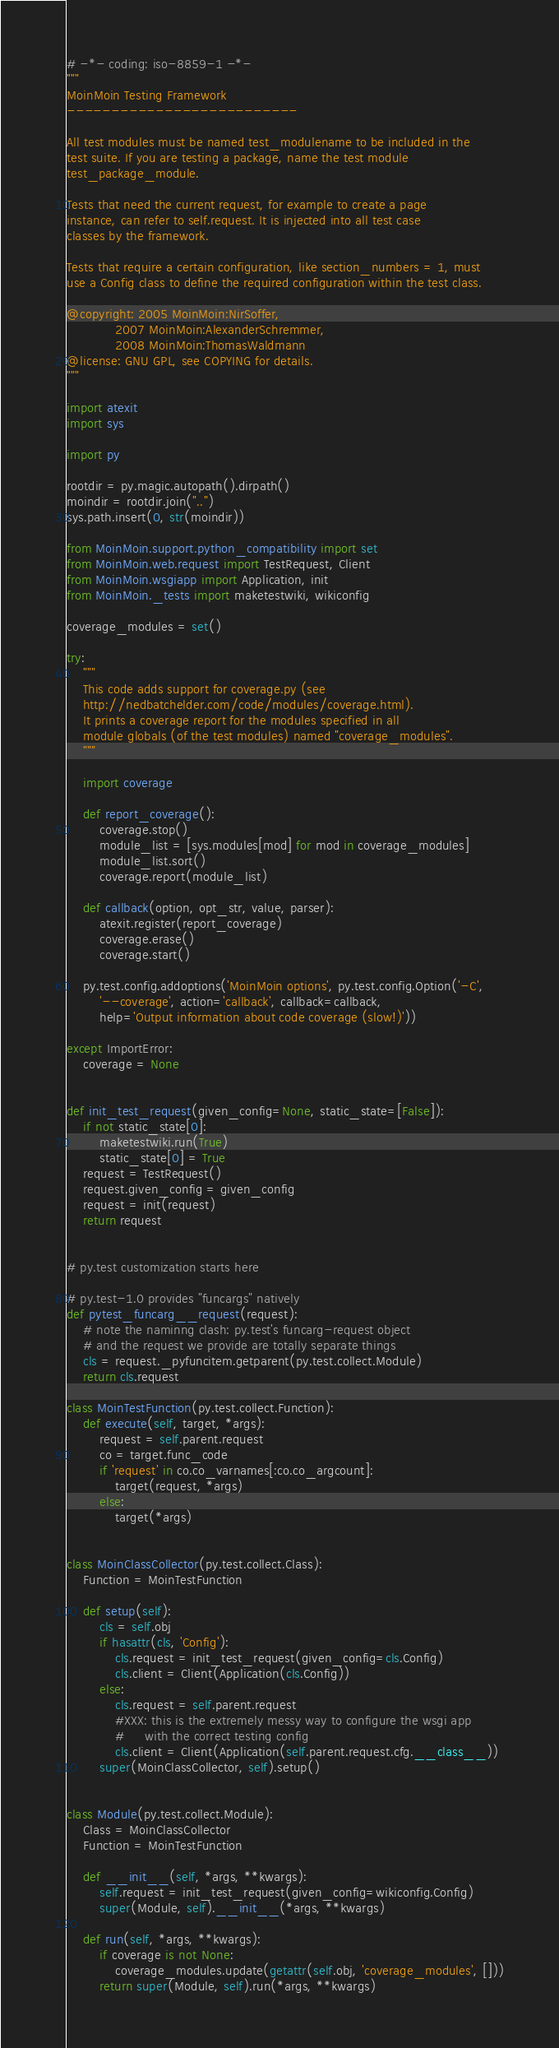<code> <loc_0><loc_0><loc_500><loc_500><_Python_># -*- coding: iso-8859-1 -*-
"""
MoinMoin Testing Framework
--------------------------

All test modules must be named test_modulename to be included in the
test suite. If you are testing a package, name the test module
test_package_module.

Tests that need the current request, for example to create a page
instance, can refer to self.request. It is injected into all test case
classes by the framework.

Tests that require a certain configuration, like section_numbers = 1, must
use a Config class to define the required configuration within the test class.

@copyright: 2005 MoinMoin:NirSoffer,
            2007 MoinMoin:AlexanderSchremmer,
            2008 MoinMoin:ThomasWaldmann
@license: GNU GPL, see COPYING for details.
"""

import atexit
import sys

import py

rootdir = py.magic.autopath().dirpath()
moindir = rootdir.join("..")
sys.path.insert(0, str(moindir))

from MoinMoin.support.python_compatibility import set
from MoinMoin.web.request import TestRequest, Client
from MoinMoin.wsgiapp import Application, init
from MoinMoin._tests import maketestwiki, wikiconfig

coverage_modules = set()

try:
    """
    This code adds support for coverage.py (see
    http://nedbatchelder.com/code/modules/coverage.html).
    It prints a coverage report for the modules specified in all
    module globals (of the test modules) named "coverage_modules".
    """

    import coverage

    def report_coverage():
        coverage.stop()
        module_list = [sys.modules[mod] for mod in coverage_modules]
        module_list.sort()
        coverage.report(module_list)

    def callback(option, opt_str, value, parser):
        atexit.register(report_coverage)
        coverage.erase()
        coverage.start()

    py.test.config.addoptions('MoinMoin options', py.test.config.Option('-C',
        '--coverage', action='callback', callback=callback,
        help='Output information about code coverage (slow!)'))

except ImportError:
    coverage = None


def init_test_request(given_config=None, static_state=[False]):
    if not static_state[0]:
        maketestwiki.run(True)
        static_state[0] = True
    request = TestRequest()
    request.given_config = given_config
    request = init(request)
    return request


# py.test customization starts here

# py.test-1.0 provides "funcargs" natively
def pytest_funcarg__request(request):
    # note the naminng clash: py.test's funcarg-request object
    # and the request we provide are totally separate things
    cls = request._pyfuncitem.getparent(py.test.collect.Module)
    return cls.request

class MoinTestFunction(py.test.collect.Function):
    def execute(self, target, *args):
        request = self.parent.request
        co = target.func_code
        if 'request' in co.co_varnames[:co.co_argcount]:
            target(request, *args)
        else:
            target(*args)


class MoinClassCollector(py.test.collect.Class):
    Function = MoinTestFunction

    def setup(self):
        cls = self.obj
        if hasattr(cls, 'Config'):
            cls.request = init_test_request(given_config=cls.Config)
            cls.client = Client(Application(cls.Config))
        else:
            cls.request = self.parent.request
            #XXX: this is the extremely messy way to configure the wsgi app
            #     with the correct testing config
            cls.client = Client(Application(self.parent.request.cfg.__class__))
        super(MoinClassCollector, self).setup()


class Module(py.test.collect.Module):
    Class = MoinClassCollector
    Function = MoinTestFunction

    def __init__(self, *args, **kwargs):
        self.request = init_test_request(given_config=wikiconfig.Config)
        super(Module, self).__init__(*args, **kwargs)

    def run(self, *args, **kwargs):
        if coverage is not None:
            coverage_modules.update(getattr(self.obj, 'coverage_modules', []))
        return super(Module, self).run(*args, **kwargs)
</code> 